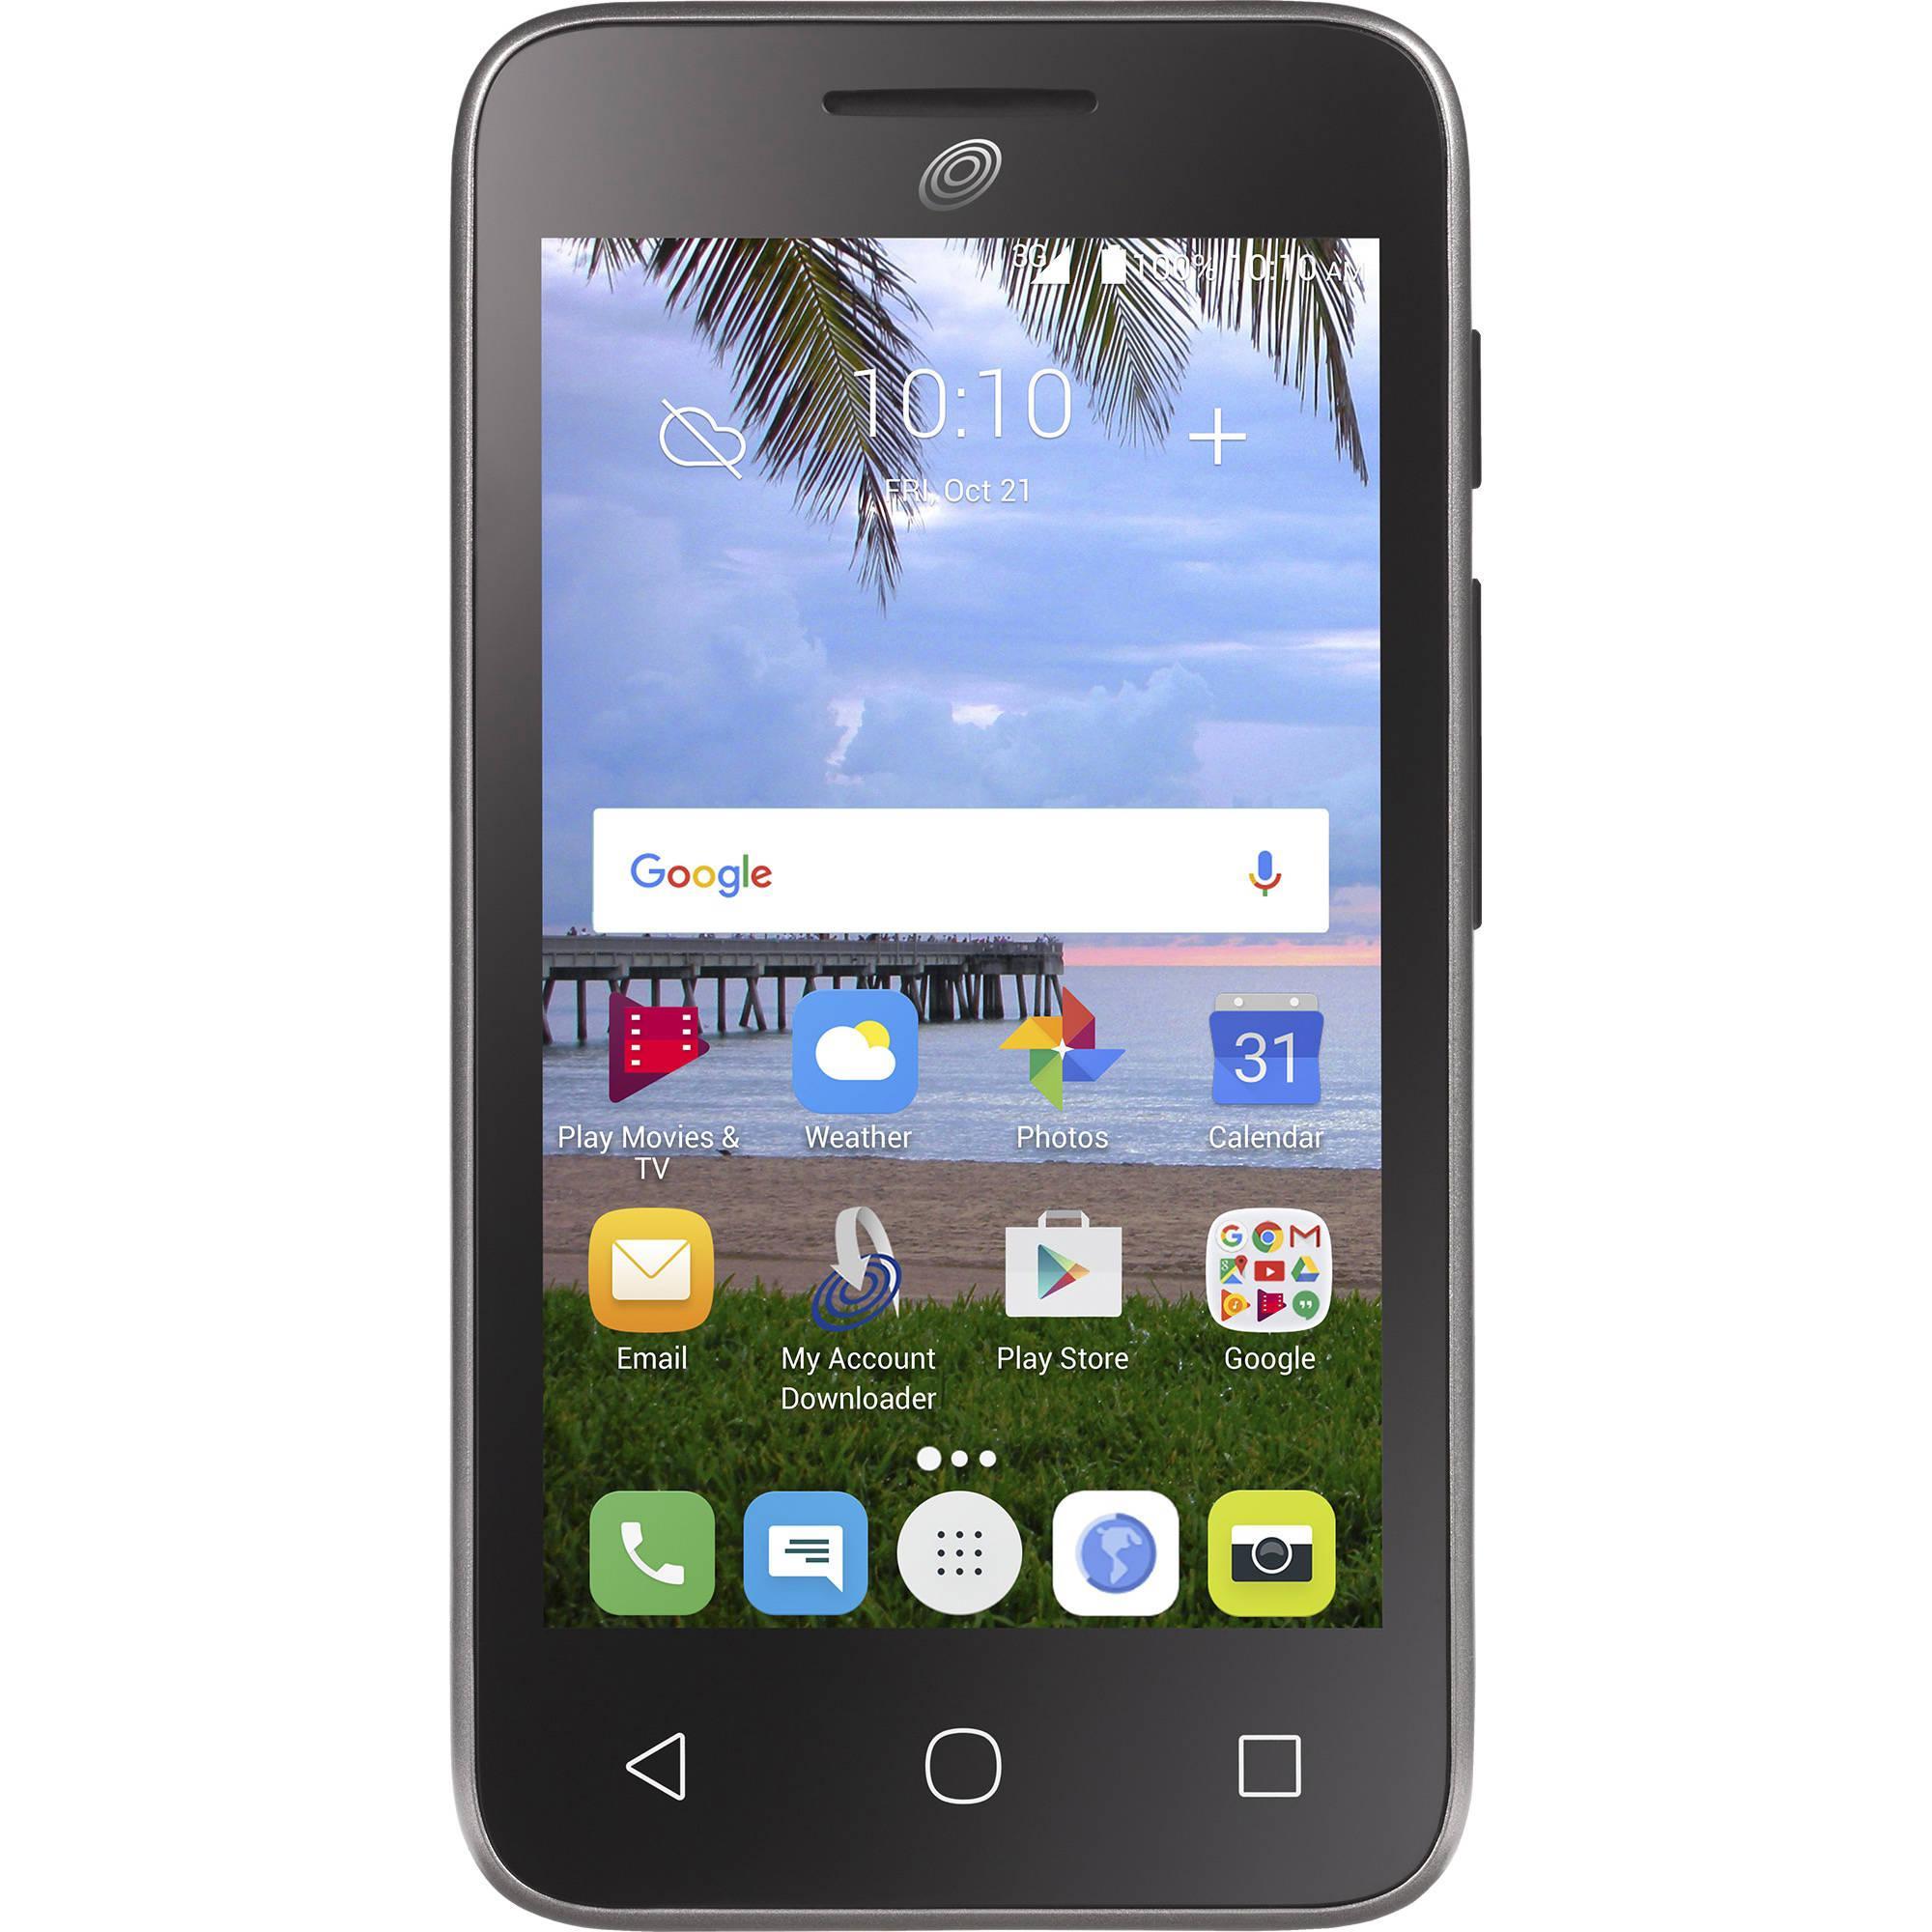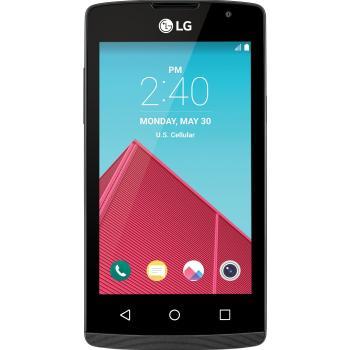The first image is the image on the left, the second image is the image on the right. For the images displayed, is the sentence "The phone on the left has a beach wallpaper, the phone on the right has an abstract wallpaper." factually correct? Answer yes or no. Yes. The first image is the image on the left, the second image is the image on the right. For the images displayed, is the sentence "There are two full black phones." factually correct? Answer yes or no. Yes. 